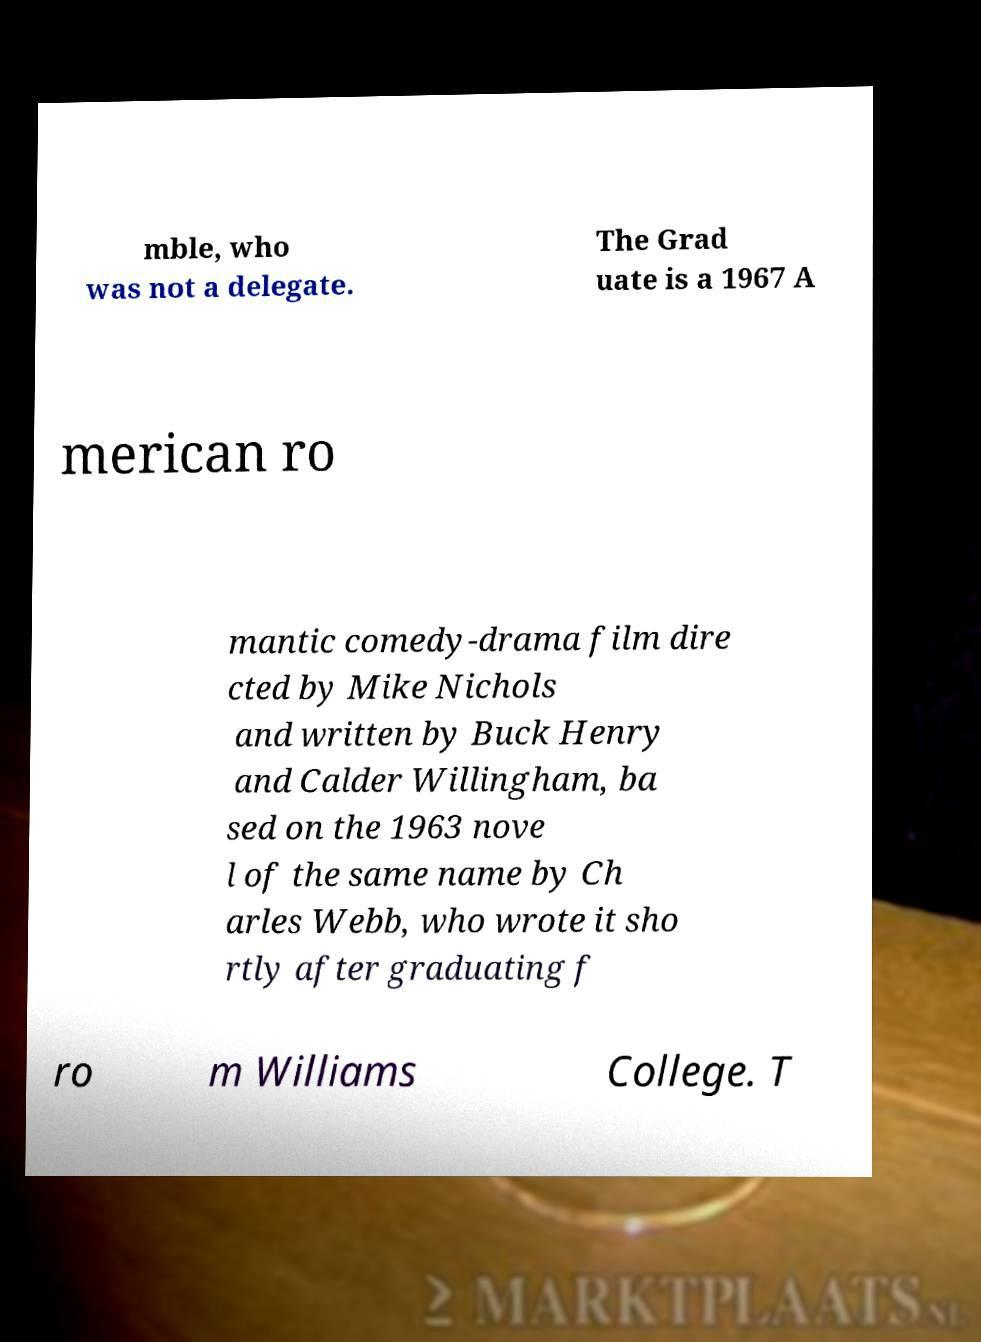Please identify and transcribe the text found in this image. mble, who was not a delegate. The Grad uate is a 1967 A merican ro mantic comedy-drama film dire cted by Mike Nichols and written by Buck Henry and Calder Willingham, ba sed on the 1963 nove l of the same name by Ch arles Webb, who wrote it sho rtly after graduating f ro m Williams College. T 